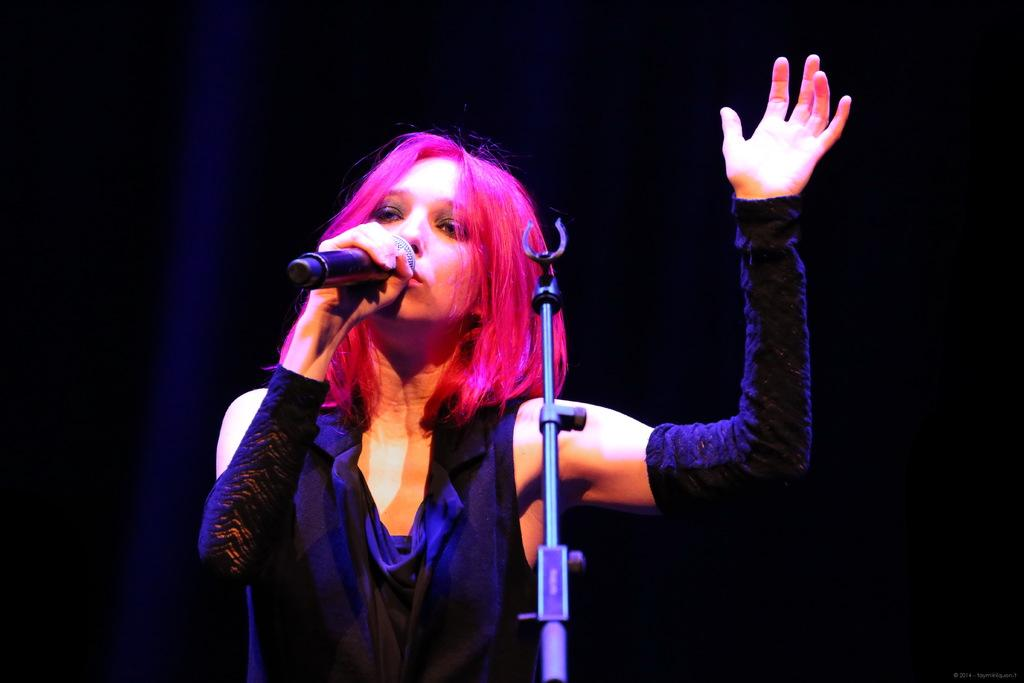Who is the main subject in the image? There is a woman in the image. What is the woman doing in the image? The woman is singing. What is the woman holding in the image? The woman is holding a microphone. What color are the clothes the woman is wearing? The woman is wearing black clothes. What is present in front of the woman in the image? There is a microphone stand in front of the woman. How would you describe the lighting in the image? The background of the image is dark. What type of powder is being applied to the woman's body in the image? There is no powder or body present in the image; it features a woman singing while holding a microphone. 